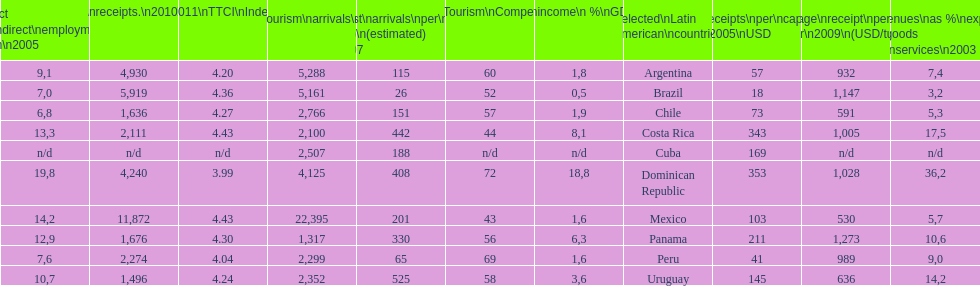Which country had the least amount of tourism income in 2003? Brazil. 